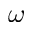Convert formula to latex. <formula><loc_0><loc_0><loc_500><loc_500>\omega</formula> 